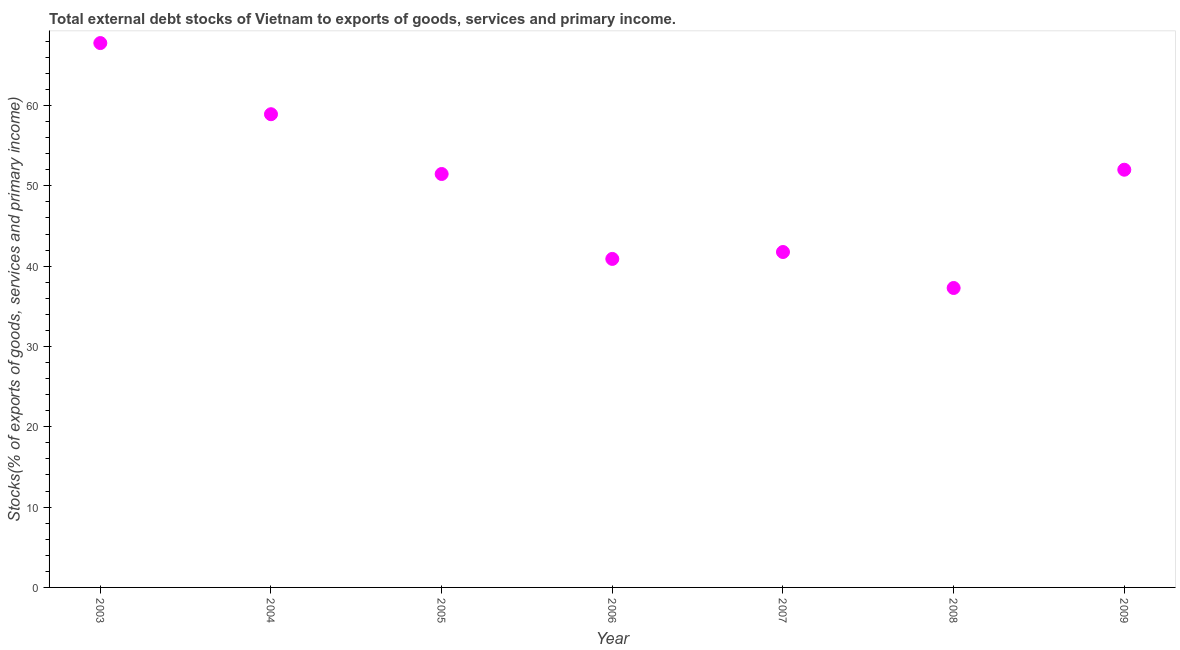What is the external debt stocks in 2007?
Your response must be concise. 41.76. Across all years, what is the maximum external debt stocks?
Provide a succinct answer. 67.78. Across all years, what is the minimum external debt stocks?
Make the answer very short. 37.28. In which year was the external debt stocks maximum?
Your answer should be very brief. 2003. What is the sum of the external debt stocks?
Provide a succinct answer. 350.12. What is the difference between the external debt stocks in 2003 and 2008?
Keep it short and to the point. 30.49. What is the average external debt stocks per year?
Offer a terse response. 50.02. What is the median external debt stocks?
Your answer should be very brief. 51.47. What is the ratio of the external debt stocks in 2005 to that in 2006?
Offer a very short reply. 1.26. Is the external debt stocks in 2003 less than that in 2004?
Your answer should be compact. No. What is the difference between the highest and the second highest external debt stocks?
Your response must be concise. 8.86. Is the sum of the external debt stocks in 2003 and 2009 greater than the maximum external debt stocks across all years?
Provide a short and direct response. Yes. What is the difference between the highest and the lowest external debt stocks?
Offer a terse response. 30.49. In how many years, is the external debt stocks greater than the average external debt stocks taken over all years?
Make the answer very short. 4. How many years are there in the graph?
Offer a very short reply. 7. What is the difference between two consecutive major ticks on the Y-axis?
Ensure brevity in your answer.  10. Are the values on the major ticks of Y-axis written in scientific E-notation?
Provide a succinct answer. No. Does the graph contain any zero values?
Keep it short and to the point. No. Does the graph contain grids?
Make the answer very short. No. What is the title of the graph?
Offer a very short reply. Total external debt stocks of Vietnam to exports of goods, services and primary income. What is the label or title of the X-axis?
Provide a short and direct response. Year. What is the label or title of the Y-axis?
Your response must be concise. Stocks(% of exports of goods, services and primary income). What is the Stocks(% of exports of goods, services and primary income) in 2003?
Your answer should be compact. 67.78. What is the Stocks(% of exports of goods, services and primary income) in 2004?
Provide a succinct answer. 58.92. What is the Stocks(% of exports of goods, services and primary income) in 2005?
Provide a short and direct response. 51.47. What is the Stocks(% of exports of goods, services and primary income) in 2006?
Keep it short and to the point. 40.9. What is the Stocks(% of exports of goods, services and primary income) in 2007?
Offer a terse response. 41.76. What is the Stocks(% of exports of goods, services and primary income) in 2008?
Your answer should be very brief. 37.28. What is the Stocks(% of exports of goods, services and primary income) in 2009?
Provide a succinct answer. 52.01. What is the difference between the Stocks(% of exports of goods, services and primary income) in 2003 and 2004?
Make the answer very short. 8.86. What is the difference between the Stocks(% of exports of goods, services and primary income) in 2003 and 2005?
Your response must be concise. 16.3. What is the difference between the Stocks(% of exports of goods, services and primary income) in 2003 and 2006?
Give a very brief answer. 26.87. What is the difference between the Stocks(% of exports of goods, services and primary income) in 2003 and 2007?
Provide a short and direct response. 26.01. What is the difference between the Stocks(% of exports of goods, services and primary income) in 2003 and 2008?
Your answer should be compact. 30.49. What is the difference between the Stocks(% of exports of goods, services and primary income) in 2003 and 2009?
Provide a succinct answer. 15.77. What is the difference between the Stocks(% of exports of goods, services and primary income) in 2004 and 2005?
Your response must be concise. 7.44. What is the difference between the Stocks(% of exports of goods, services and primary income) in 2004 and 2006?
Give a very brief answer. 18.02. What is the difference between the Stocks(% of exports of goods, services and primary income) in 2004 and 2007?
Offer a very short reply. 17.16. What is the difference between the Stocks(% of exports of goods, services and primary income) in 2004 and 2008?
Give a very brief answer. 21.64. What is the difference between the Stocks(% of exports of goods, services and primary income) in 2004 and 2009?
Provide a short and direct response. 6.91. What is the difference between the Stocks(% of exports of goods, services and primary income) in 2005 and 2006?
Offer a very short reply. 10.57. What is the difference between the Stocks(% of exports of goods, services and primary income) in 2005 and 2007?
Provide a succinct answer. 9.71. What is the difference between the Stocks(% of exports of goods, services and primary income) in 2005 and 2008?
Offer a terse response. 14.19. What is the difference between the Stocks(% of exports of goods, services and primary income) in 2005 and 2009?
Your answer should be very brief. -0.53. What is the difference between the Stocks(% of exports of goods, services and primary income) in 2006 and 2007?
Make the answer very short. -0.86. What is the difference between the Stocks(% of exports of goods, services and primary income) in 2006 and 2008?
Keep it short and to the point. 3.62. What is the difference between the Stocks(% of exports of goods, services and primary income) in 2006 and 2009?
Your response must be concise. -11.11. What is the difference between the Stocks(% of exports of goods, services and primary income) in 2007 and 2008?
Keep it short and to the point. 4.48. What is the difference between the Stocks(% of exports of goods, services and primary income) in 2007 and 2009?
Keep it short and to the point. -10.25. What is the difference between the Stocks(% of exports of goods, services and primary income) in 2008 and 2009?
Your response must be concise. -14.73. What is the ratio of the Stocks(% of exports of goods, services and primary income) in 2003 to that in 2004?
Keep it short and to the point. 1.15. What is the ratio of the Stocks(% of exports of goods, services and primary income) in 2003 to that in 2005?
Offer a terse response. 1.32. What is the ratio of the Stocks(% of exports of goods, services and primary income) in 2003 to that in 2006?
Keep it short and to the point. 1.66. What is the ratio of the Stocks(% of exports of goods, services and primary income) in 2003 to that in 2007?
Ensure brevity in your answer.  1.62. What is the ratio of the Stocks(% of exports of goods, services and primary income) in 2003 to that in 2008?
Your answer should be compact. 1.82. What is the ratio of the Stocks(% of exports of goods, services and primary income) in 2003 to that in 2009?
Offer a terse response. 1.3. What is the ratio of the Stocks(% of exports of goods, services and primary income) in 2004 to that in 2005?
Offer a very short reply. 1.15. What is the ratio of the Stocks(% of exports of goods, services and primary income) in 2004 to that in 2006?
Ensure brevity in your answer.  1.44. What is the ratio of the Stocks(% of exports of goods, services and primary income) in 2004 to that in 2007?
Offer a terse response. 1.41. What is the ratio of the Stocks(% of exports of goods, services and primary income) in 2004 to that in 2008?
Provide a short and direct response. 1.58. What is the ratio of the Stocks(% of exports of goods, services and primary income) in 2004 to that in 2009?
Provide a succinct answer. 1.13. What is the ratio of the Stocks(% of exports of goods, services and primary income) in 2005 to that in 2006?
Offer a terse response. 1.26. What is the ratio of the Stocks(% of exports of goods, services and primary income) in 2005 to that in 2007?
Your answer should be compact. 1.23. What is the ratio of the Stocks(% of exports of goods, services and primary income) in 2005 to that in 2008?
Your response must be concise. 1.38. What is the ratio of the Stocks(% of exports of goods, services and primary income) in 2005 to that in 2009?
Give a very brief answer. 0.99. What is the ratio of the Stocks(% of exports of goods, services and primary income) in 2006 to that in 2007?
Offer a very short reply. 0.98. What is the ratio of the Stocks(% of exports of goods, services and primary income) in 2006 to that in 2008?
Make the answer very short. 1.1. What is the ratio of the Stocks(% of exports of goods, services and primary income) in 2006 to that in 2009?
Make the answer very short. 0.79. What is the ratio of the Stocks(% of exports of goods, services and primary income) in 2007 to that in 2008?
Your answer should be very brief. 1.12. What is the ratio of the Stocks(% of exports of goods, services and primary income) in 2007 to that in 2009?
Your answer should be compact. 0.8. What is the ratio of the Stocks(% of exports of goods, services and primary income) in 2008 to that in 2009?
Ensure brevity in your answer.  0.72. 